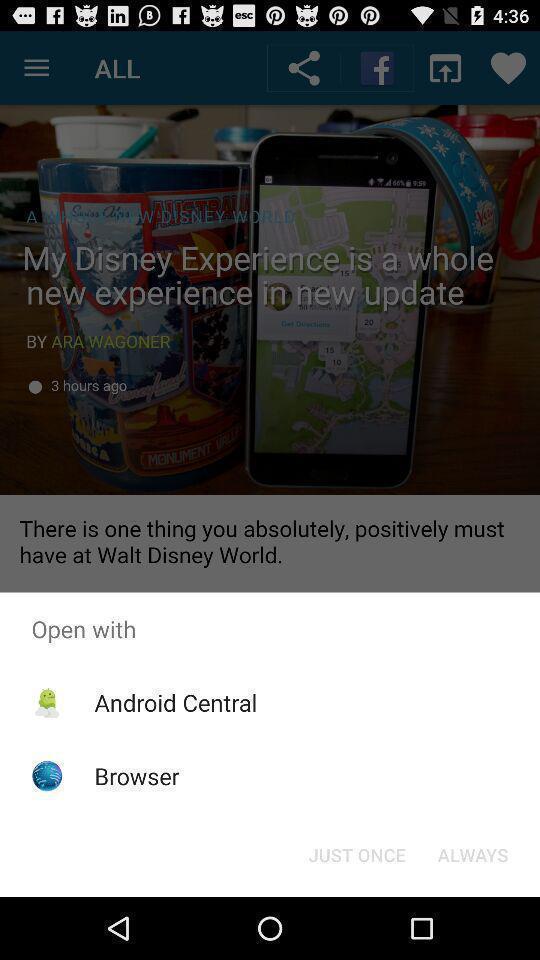Summarize the main components in this picture. Popup displaying multiple options to open an app with. 